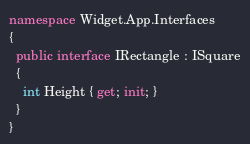Convert code to text. <code><loc_0><loc_0><loc_500><loc_500><_C#_>namespace Widget.App.Interfaces
{
  public interface IRectangle : ISquare
  {
    int Height { get; init; }
  }
}
</code> 